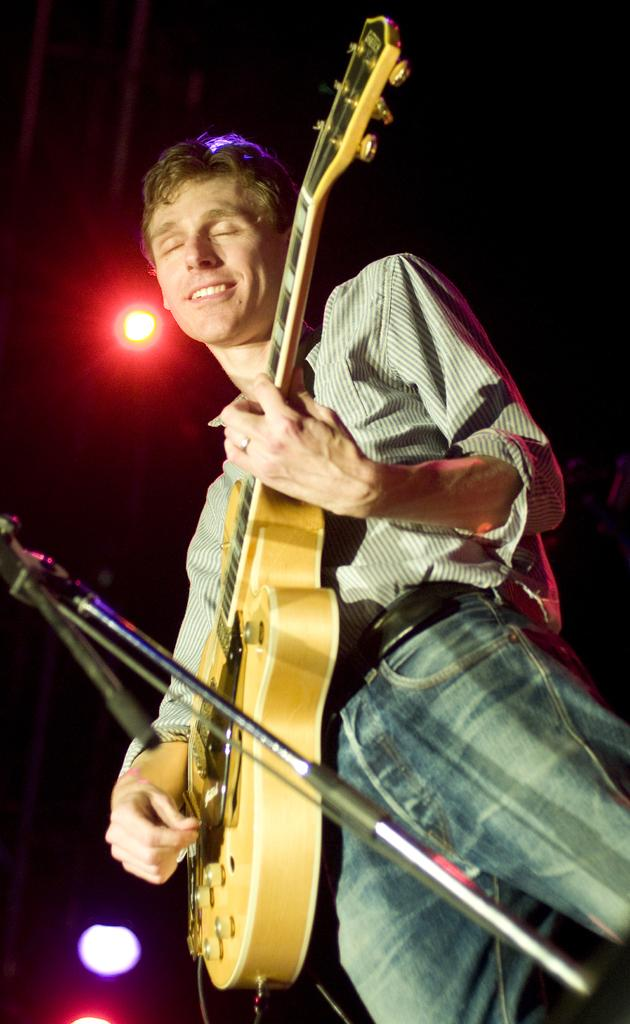What is the main subject of the image? There is a person in the image. What is the person doing in the image? The person is standing and playing a guitar. What object is present in the image that is commonly used for amplifying sound? There is a microphone in the image. What type of garden can be seen in the background of the image? There is no garden present in the image. How does the person kick the guitar during their performance? The person is not kicking the guitar in the image; they are playing it. 